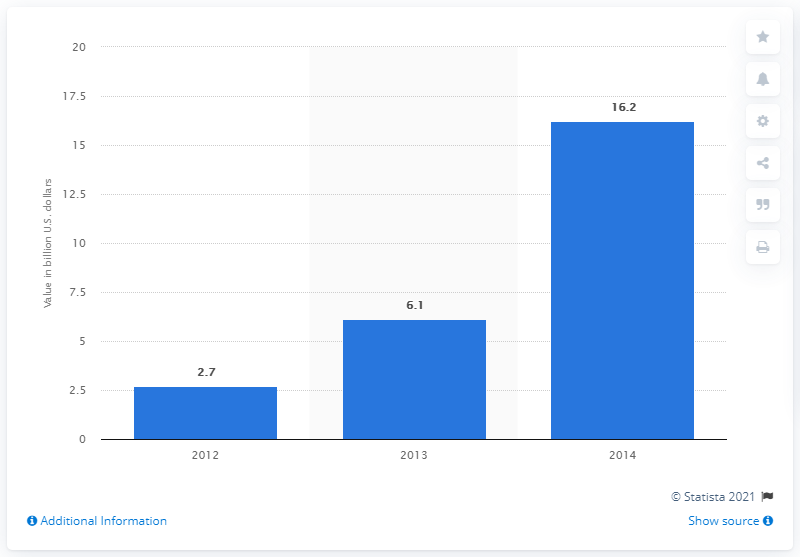Highlight a few significant elements in this photo. In 2013, crowdfunding platforms raised a significant amount of money, with the exact amount being 6.1 billion dollars. 